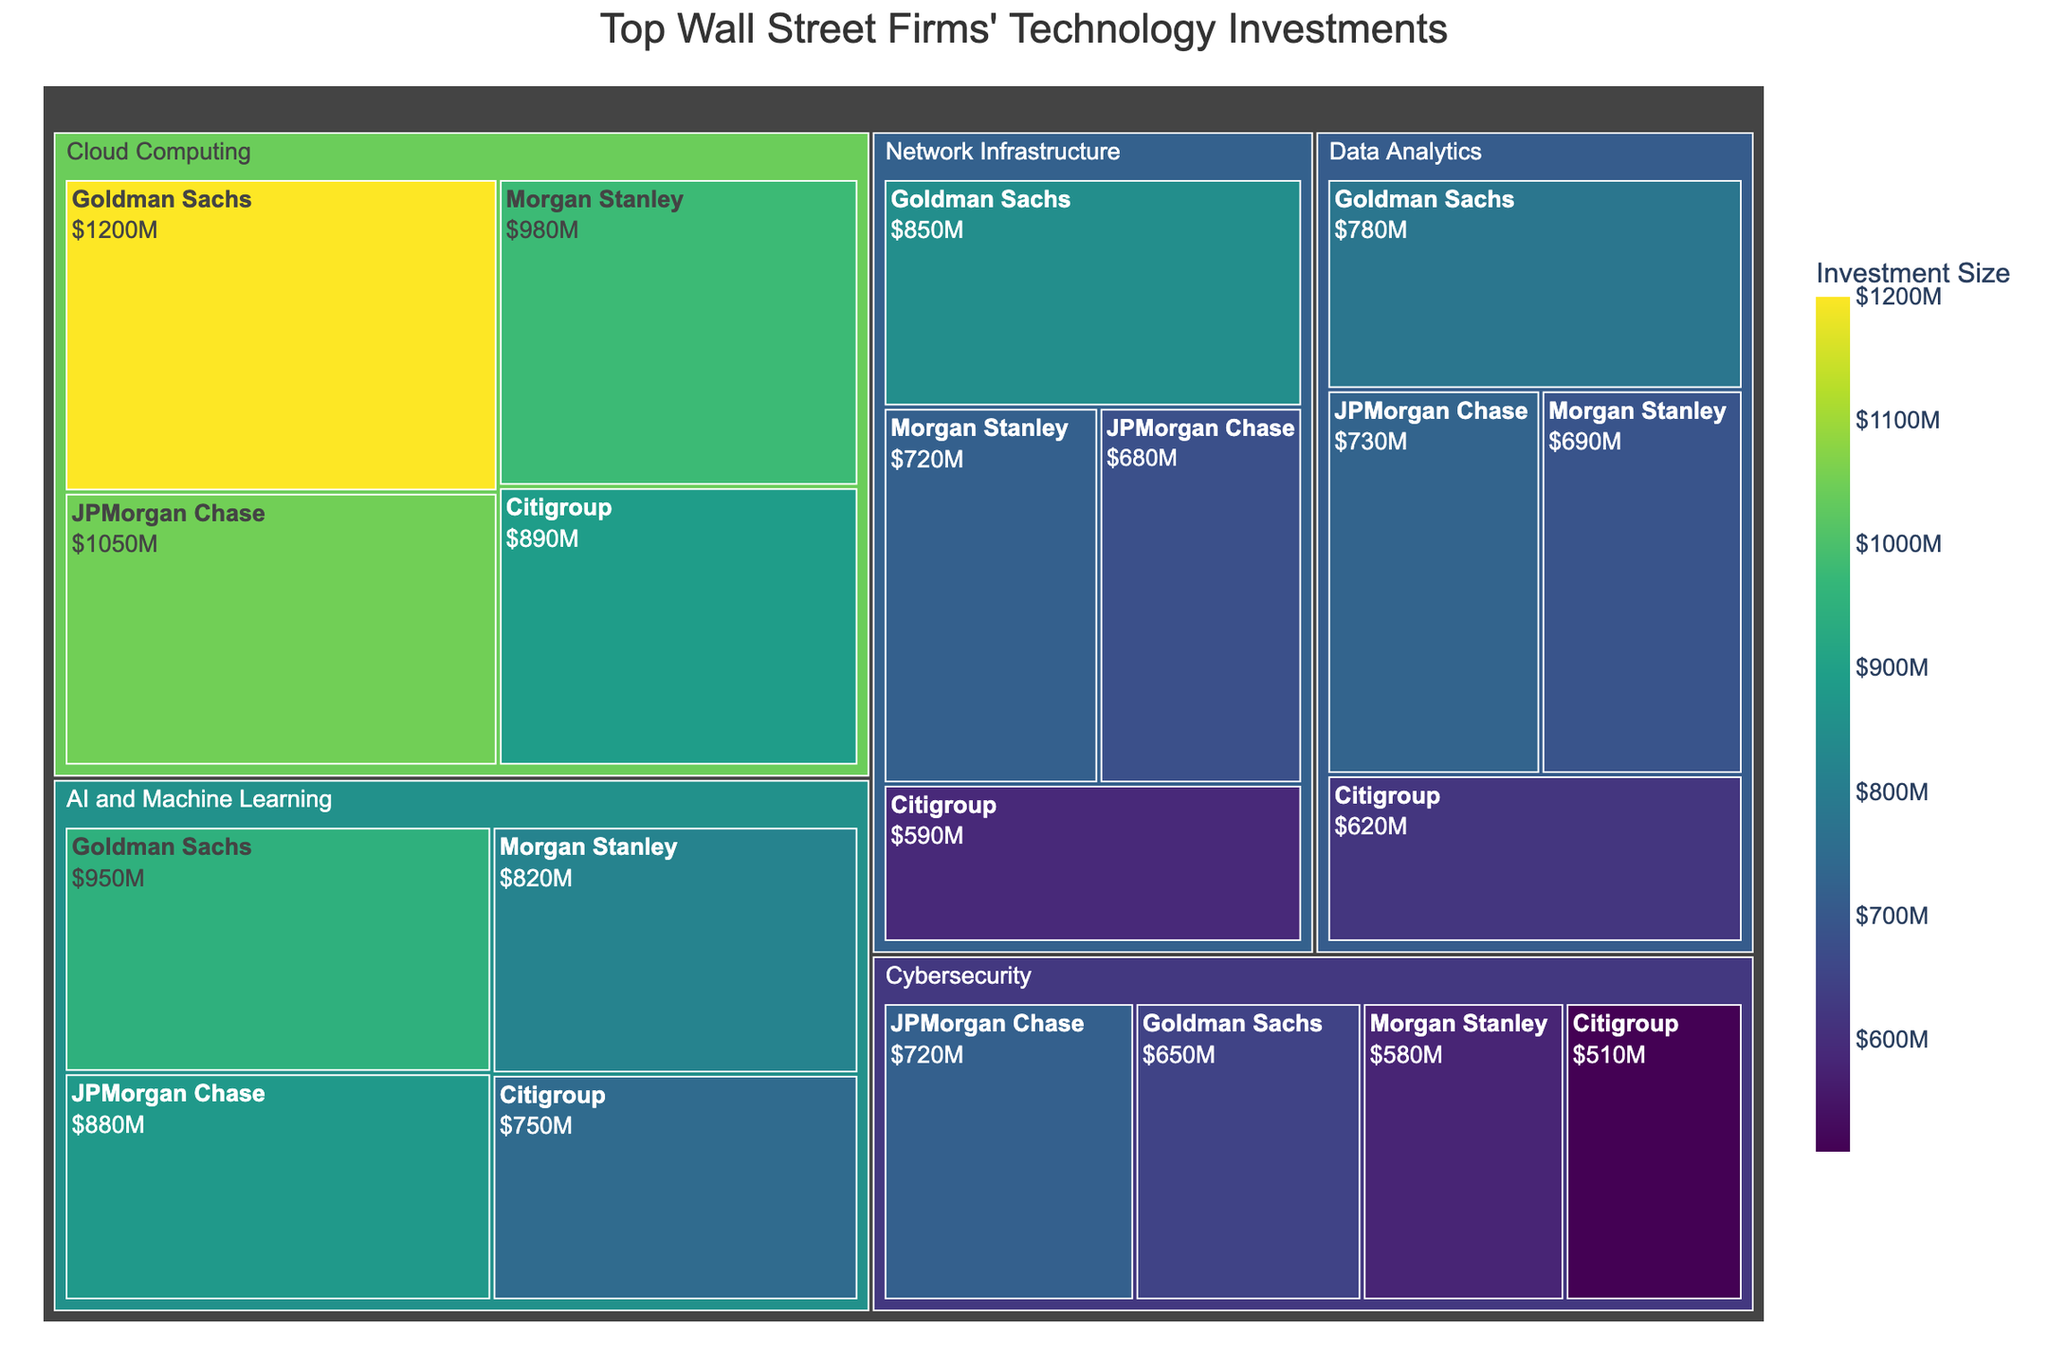What is the total investment size in Network Infrastructure by all the firms combined? To find the total investment size in Network Infrastructure, sum up the investment sizes for Goldman Sachs (850), Morgan Stanley (720), JPMorgan Chase (680), and Citigroup (590). 850 + 720 + 680 + 590 = 2840.
Answer: 2840 Which firm has the highest investment in Cloud Computing? In the Cloud Computing sector, compare the investment sizes of Goldman Sachs (1200), Morgan Stanley (980), JPMorgan Chase (1050), and Citigroup (890). The highest investment is by Goldman Sachs with 1200.
Answer: Goldman Sachs How does the investment in AI and Machine Learning for Goldman Sachs compare to Morgan Stanley? Compare the investment sizes in AI and Machine Learning for Goldman Sachs (950) and Morgan Stanley (820). Goldman Sachs has a higher investment.
Answer: Goldman Sachs What is the smallest investment size in the Data Analytics sector? In the Data Analytics sector, the investment sizes are Goldman Sachs (780), Morgan Stanley (690), JPMorgan Chase (730), and Citigroup (620). The smallest investment is by Citigroup with 620.
Answer: Citigroup What is the average investment size in the Cybersecurity sector? To find the average investment size in Cybersecurity, sum the investments for Goldman Sachs (650), Morgan Stanley (580), JPMorgan Chase (720), and Citigroup (510) and divide by the number of firms. (650 + 580 + 720 + 510) / 4 = 615.
Answer: 615 Which sector has the highest total investment from Citigroup? Sum the investments from Citigroup in each sector and compare: Network Infrastructure (590), Cloud Computing (890), Cybersecurity (510), AI and Machine Learning (750), and Data Analytics (620). The highest total investment is in Cloud Computing with 890.
Answer: Cloud Computing Comparing the total investments in all sectors, which sector has the highest investment across all firms? Sum the investments in each sector across all firms. Network Infrastructure: 2840, Cloud Computing: 4120, Cybersecurity: 2460, AI and Machine Learning: 3400, Data Analytics: 2820. The highest investment is in Cloud Computing with 4120.
Answer: Cloud Computing What is the difference between the total investments in AI and Machine Learning and Data Analytics sectors across all firms? Calculate the total investments in AI and Machine Learning (3400) and Data Analytics (2820), then find the difference. 3400 - 2820 = 580.
Answer: 580 Which firm has the lowest total investment across all sectors? Sum the investments across all sectors for each firm: Goldman Sachs (4430), Morgan Stanley (3790), JPMorgan Chase (4060), Citigroup (3360). The lowest total investment is by Citigroup with 3360.
Answer: Citigroup 